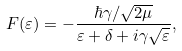Convert formula to latex. <formula><loc_0><loc_0><loc_500><loc_500>F ( \varepsilon ) = - \frac { \hbar { \gamma } / \sqrt { 2 \mu } } { \varepsilon + \delta + i \gamma \sqrt { \varepsilon } } ,</formula> 